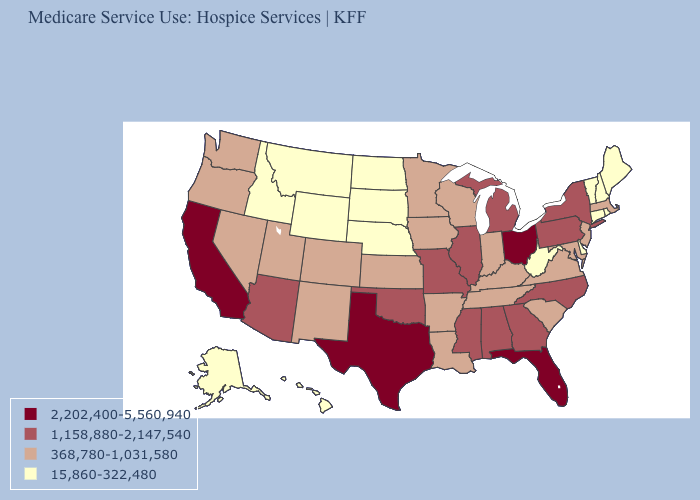What is the lowest value in the South?
Concise answer only. 15,860-322,480. Does Hawaii have the lowest value in the West?
Answer briefly. Yes. Does California have the highest value in the West?
Answer briefly. Yes. What is the lowest value in the USA?
Keep it brief. 15,860-322,480. What is the value of Hawaii?
Concise answer only. 15,860-322,480. Among the states that border New Hampshire , does Maine have the highest value?
Short answer required. No. What is the value of Tennessee?
Answer briefly. 368,780-1,031,580. What is the highest value in states that border Rhode Island?
Quick response, please. 368,780-1,031,580. Name the states that have a value in the range 368,780-1,031,580?
Write a very short answer. Arkansas, Colorado, Indiana, Iowa, Kansas, Kentucky, Louisiana, Maryland, Massachusetts, Minnesota, Nevada, New Jersey, New Mexico, Oregon, South Carolina, Tennessee, Utah, Virginia, Washington, Wisconsin. What is the lowest value in the USA?
Write a very short answer. 15,860-322,480. Among the states that border Kansas , does Oklahoma have the highest value?
Write a very short answer. Yes. How many symbols are there in the legend?
Quick response, please. 4. Name the states that have a value in the range 1,158,880-2,147,540?
Quick response, please. Alabama, Arizona, Georgia, Illinois, Michigan, Mississippi, Missouri, New York, North Carolina, Oklahoma, Pennsylvania. What is the value of Missouri?
Quick response, please. 1,158,880-2,147,540. Name the states that have a value in the range 2,202,400-5,560,940?
Answer briefly. California, Florida, Ohio, Texas. 